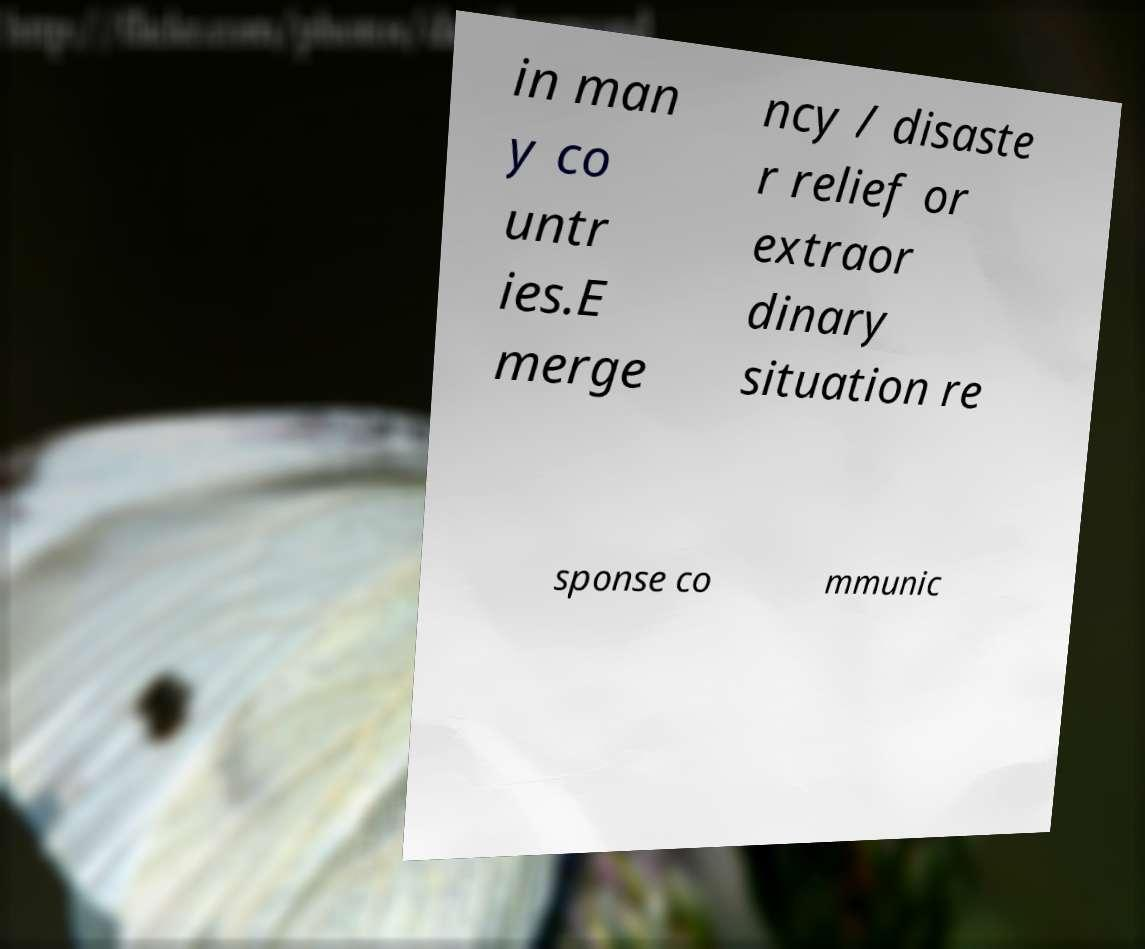Please identify and transcribe the text found in this image. in man y co untr ies.E merge ncy / disaste r relief or extraor dinary situation re sponse co mmunic 